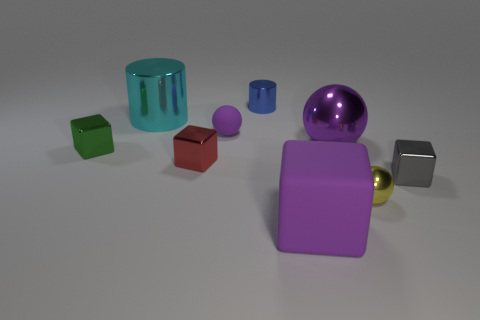There is a shiny object that is both on the left side of the tiny red thing and in front of the large purple shiny ball; what is its size?
Your answer should be very brief. Small. How many other things are there of the same shape as the tiny blue object?
Your response must be concise. 1. There is a gray shiny block; what number of big cylinders are to the left of it?
Offer a very short reply. 1. Are there fewer big purple things that are to the right of the large purple metallic object than large cyan metallic objects to the left of the large cyan cylinder?
Make the answer very short. No. There is a thing that is to the left of the big shiny thing behind the shiny sphere on the left side of the small shiny ball; what shape is it?
Your answer should be compact. Cube. There is a metallic thing that is both behind the large purple ball and to the right of the cyan shiny thing; what is its shape?
Provide a short and direct response. Cylinder. Are there any gray objects that have the same material as the green thing?
Your answer should be very brief. Yes. There is a matte thing that is the same color as the big cube; what is its size?
Your answer should be very brief. Small. What is the color of the metallic cylinder in front of the small blue shiny object?
Provide a short and direct response. Cyan. There is a gray shiny thing; does it have the same shape as the large thing that is in front of the small green thing?
Your answer should be very brief. Yes. 